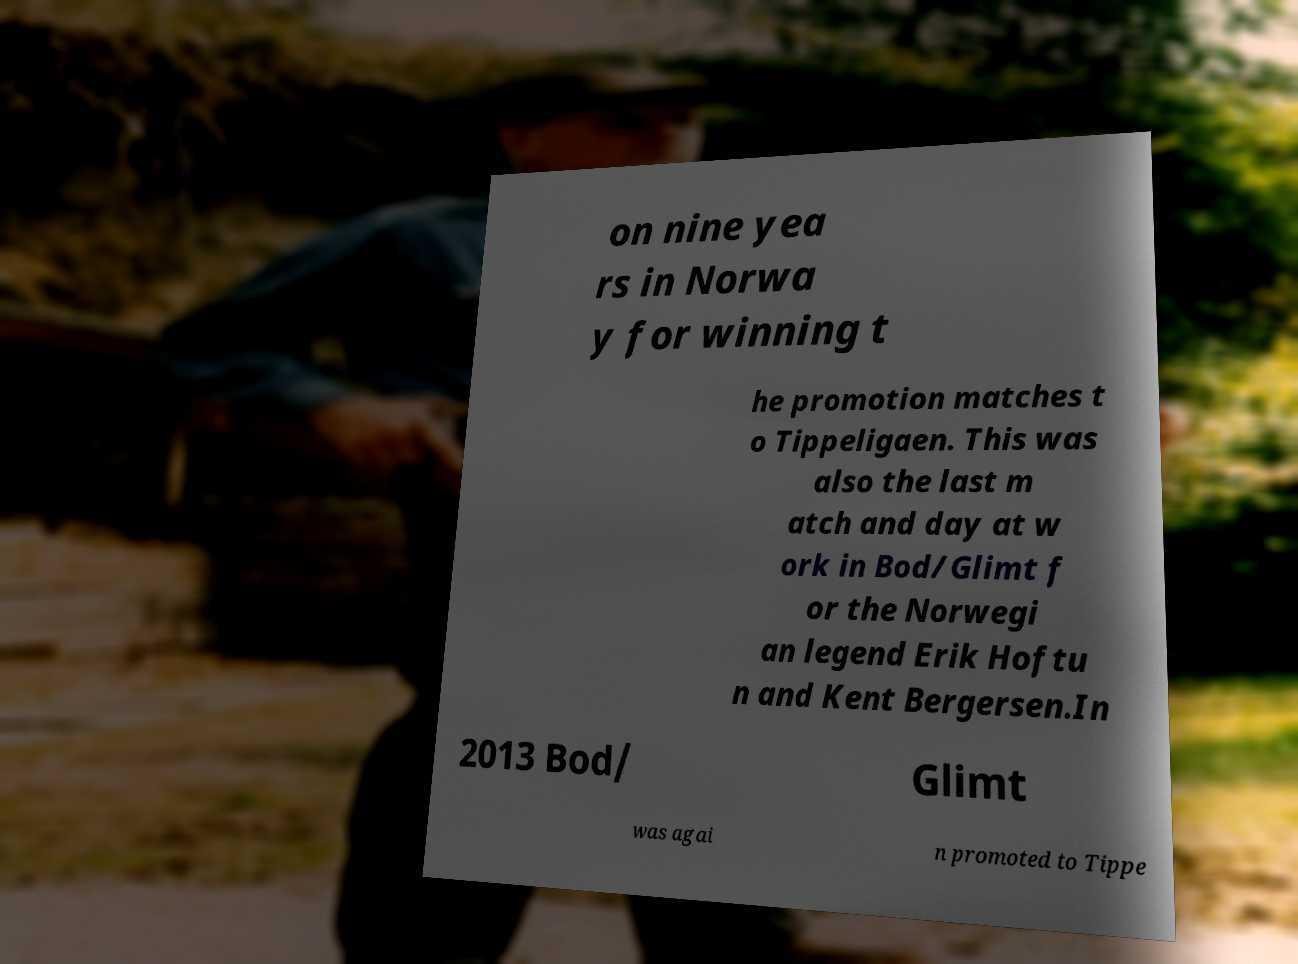There's text embedded in this image that I need extracted. Can you transcribe it verbatim? on nine yea rs in Norwa y for winning t he promotion matches t o Tippeligaen. This was also the last m atch and day at w ork in Bod/Glimt f or the Norwegi an legend Erik Hoftu n and Kent Bergersen.In 2013 Bod/ Glimt was agai n promoted to Tippe 